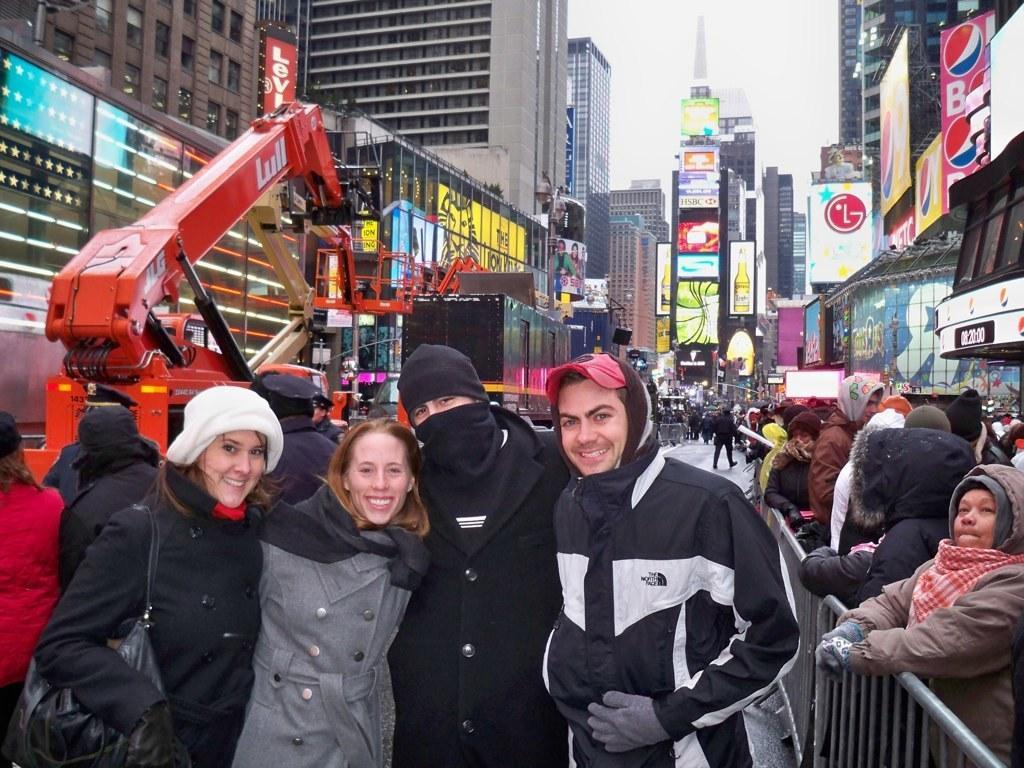Please provide a concise description of this image. In the image there are few people in the foreground they are posing for the photo and behind them there is a crane and also crowd beside the road. Around the road there are buildings and shopping malls. 